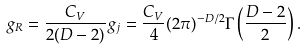<formula> <loc_0><loc_0><loc_500><loc_500>g _ { R } = \frac { C _ { V } } { 2 ( D - 2 ) } g _ { j } = \frac { C _ { V } } { 4 } ( 2 \pi ) ^ { - D / 2 } \Gamma \left ( \frac { D - 2 } { 2 } \right ) .</formula> 